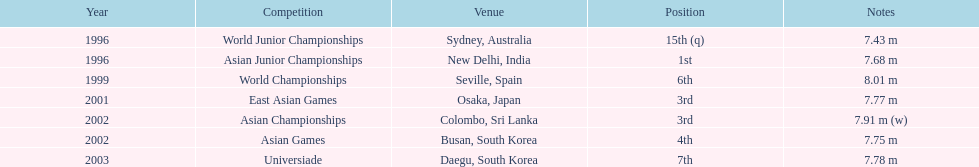Would you be able to parse every entry in this table? {'header': ['Year', 'Competition', 'Venue', 'Position', 'Notes'], 'rows': [['1996', 'World Junior Championships', 'Sydney, Australia', '15th (q)', '7.43 m'], ['1996', 'Asian Junior Championships', 'New Delhi, India', '1st', '7.68 m'], ['1999', 'World Championships', 'Seville, Spain', '6th', '8.01 m'], ['2001', 'East Asian Games', 'Osaka, Japan', '3rd', '7.77 m'], ['2002', 'Asian Championships', 'Colombo, Sri Lanka', '3rd', '7.91 m (w)'], ['2002', 'Asian Games', 'Busan, South Korea', '4th', '7.75 m'], ['2003', 'Universiade', 'Daegu, South Korea', '7th', '7.78 m']]} In what year did someone first achieve the 3rd place? 2001. 